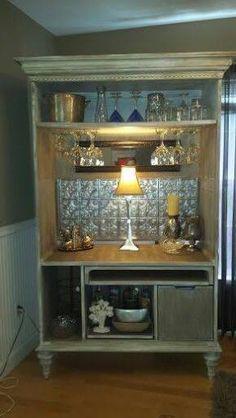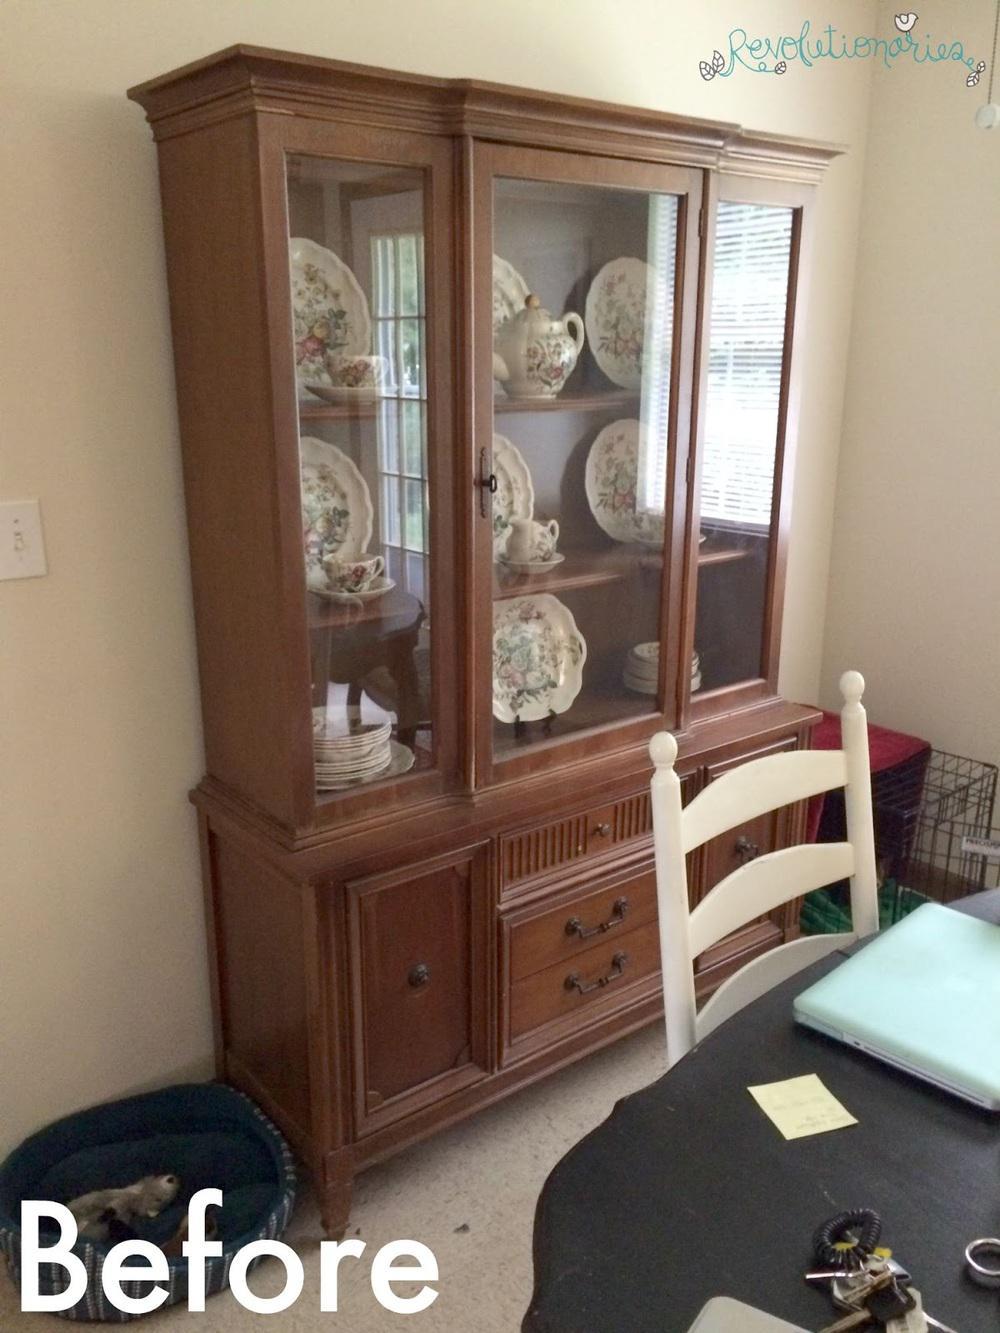The first image is the image on the left, the second image is the image on the right. Evaluate the accuracy of this statement regarding the images: "A wooden painted hutch has a bottom door open that shows an X shaped space for storing bottles of wine, and glasses hanging upside down in the upper section.". Is it true? Answer yes or no. No. The first image is the image on the left, the second image is the image on the right. For the images displayed, is the sentence "A brown cabinet is used for storage in the image on the right." factually correct? Answer yes or no. Yes. 